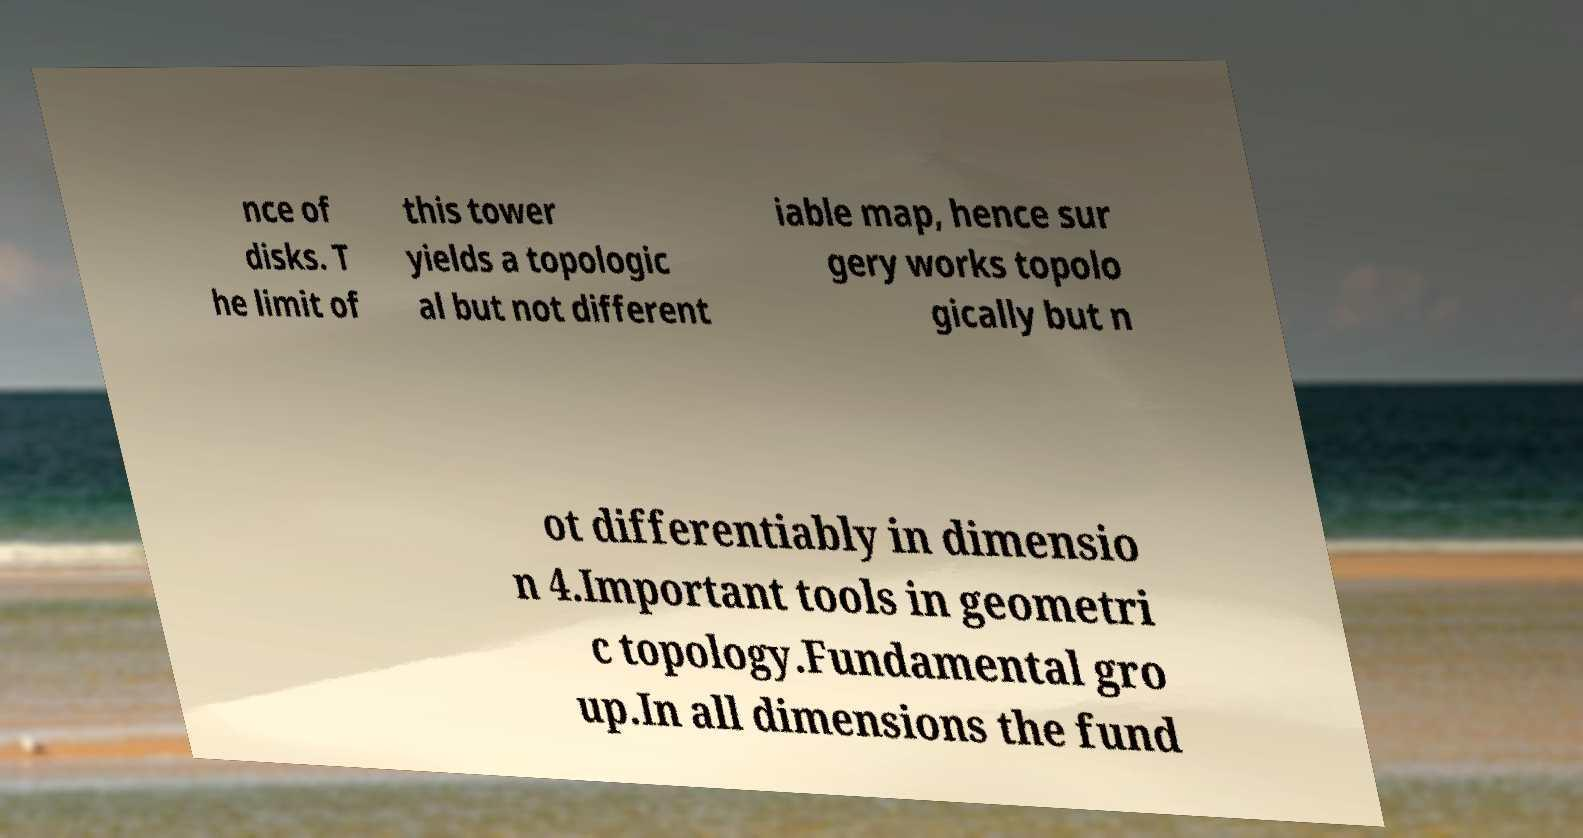Could you extract and type out the text from this image? nce of disks. T he limit of this tower yields a topologic al but not different iable map, hence sur gery works topolo gically but n ot differentiably in dimensio n 4.Important tools in geometri c topology.Fundamental gro up.In all dimensions the fund 